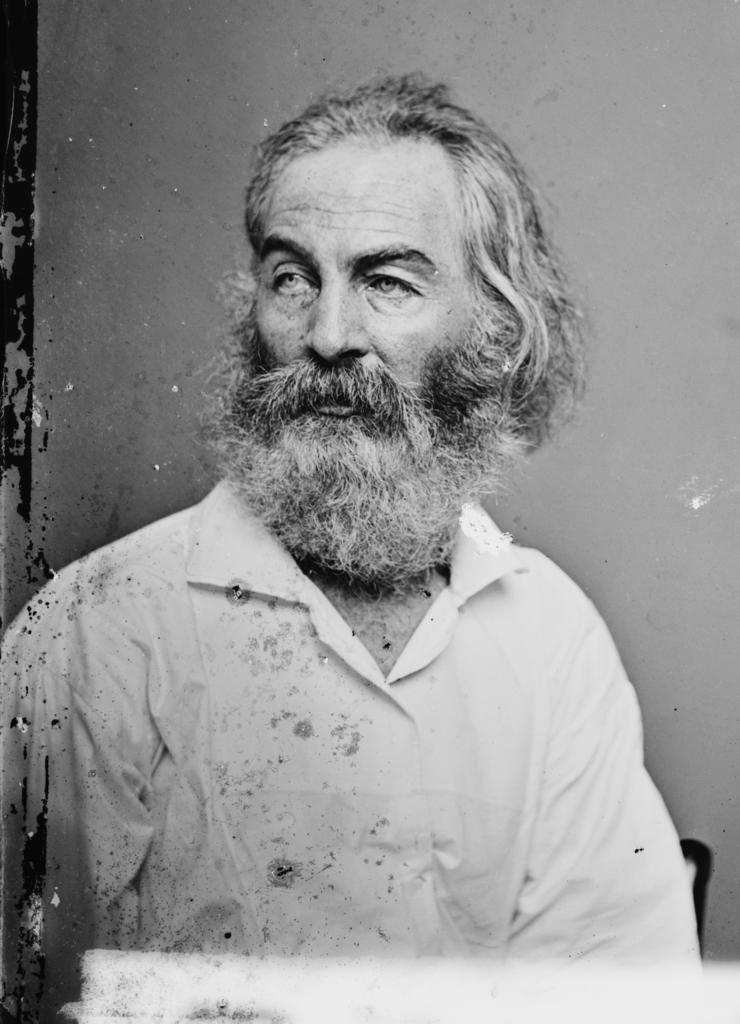Who is present in the image? There is a man in the image. What is the man wearing? The man is wearing a white shirt. What can be seen in the background of the image? There is a wall in the background of the image. How many children are playing with the rabbits in the image? There are no children or rabbits present in the image; it only features a man wearing a white shirt with a wall in the background. 